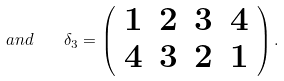<formula> <loc_0><loc_0><loc_500><loc_500>a n d \quad \delta _ { 3 } = \left ( \begin{array} { c c c c } 1 & 2 & 3 & 4 \\ 4 & 3 & 2 & 1 \end{array} \right ) .</formula> 